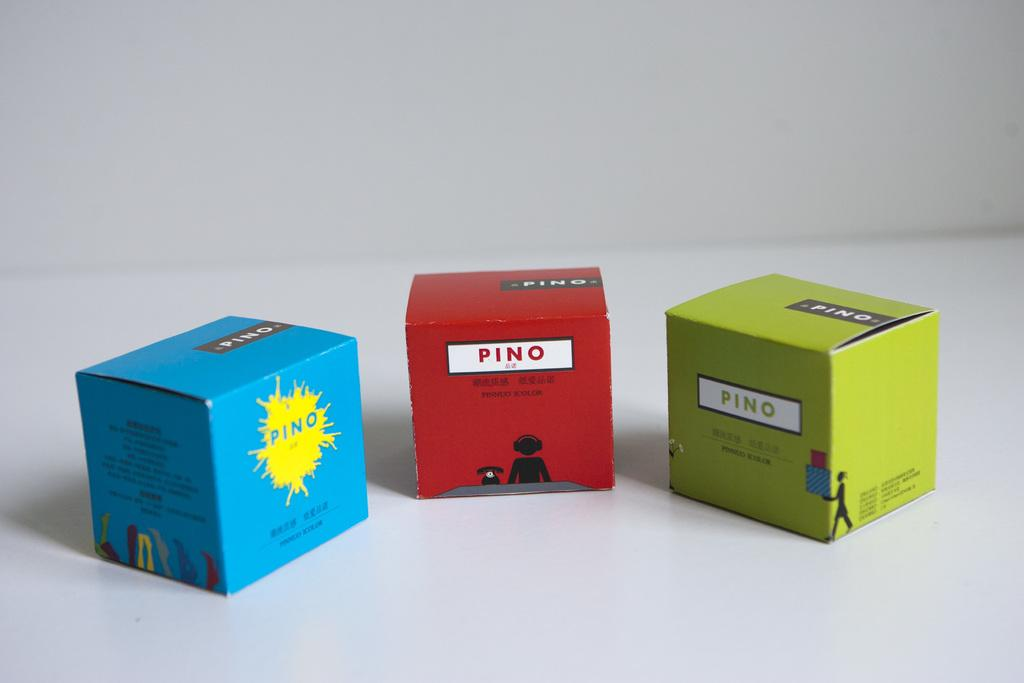Provide a one-sentence caption for the provided image. Three boxes with the word Pino on them are arranged in a curved row. 